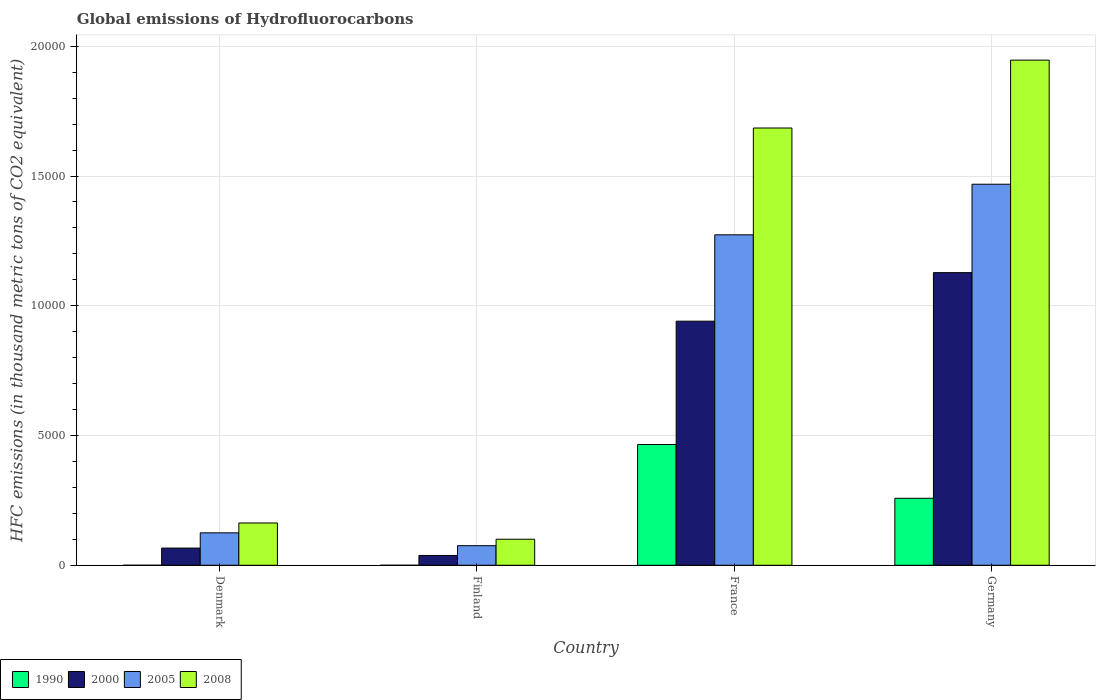Are the number of bars per tick equal to the number of legend labels?
Keep it short and to the point. Yes. What is the label of the 3rd group of bars from the left?
Offer a terse response. France. What is the global emissions of Hydrofluorocarbons in 2008 in France?
Make the answer very short. 1.69e+04. Across all countries, what is the maximum global emissions of Hydrofluorocarbons in 2005?
Give a very brief answer. 1.47e+04. Across all countries, what is the minimum global emissions of Hydrofluorocarbons in 2008?
Offer a very short reply. 1003.2. In which country was the global emissions of Hydrofluorocarbons in 2005 minimum?
Your answer should be compact. Finland. What is the total global emissions of Hydrofluorocarbons in 2000 in the graph?
Keep it short and to the point. 2.17e+04. What is the difference between the global emissions of Hydrofluorocarbons in 1990 in Finland and that in France?
Keep it short and to the point. -4654.2. What is the difference between the global emissions of Hydrofluorocarbons in 2008 in France and the global emissions of Hydrofluorocarbons in 2005 in Finland?
Your answer should be compact. 1.61e+04. What is the average global emissions of Hydrofluorocarbons in 2000 per country?
Keep it short and to the point. 5431.1. What is the difference between the global emissions of Hydrofluorocarbons of/in 2005 and global emissions of Hydrofluorocarbons of/in 1990 in Finland?
Your answer should be compact. 754.8. What is the ratio of the global emissions of Hydrofluorocarbons in 2008 in Denmark to that in France?
Offer a very short reply. 0.1. Is the global emissions of Hydrofluorocarbons in 2005 in Denmark less than that in France?
Offer a terse response. Yes. Is the difference between the global emissions of Hydrofluorocarbons in 2005 in Denmark and Finland greater than the difference between the global emissions of Hydrofluorocarbons in 1990 in Denmark and Finland?
Offer a terse response. Yes. What is the difference between the highest and the second highest global emissions of Hydrofluorocarbons in 2005?
Keep it short and to the point. -1.34e+04. What is the difference between the highest and the lowest global emissions of Hydrofluorocarbons in 2005?
Your response must be concise. 1.39e+04. Is the sum of the global emissions of Hydrofluorocarbons in 2000 in Finland and Germany greater than the maximum global emissions of Hydrofluorocarbons in 1990 across all countries?
Keep it short and to the point. Yes. Is it the case that in every country, the sum of the global emissions of Hydrofluorocarbons in 2008 and global emissions of Hydrofluorocarbons in 2005 is greater than the sum of global emissions of Hydrofluorocarbons in 2000 and global emissions of Hydrofluorocarbons in 1990?
Your response must be concise. Yes. How many bars are there?
Keep it short and to the point. 16. What is the difference between two consecutive major ticks on the Y-axis?
Your response must be concise. 5000. Are the values on the major ticks of Y-axis written in scientific E-notation?
Keep it short and to the point. No. Does the graph contain grids?
Offer a very short reply. Yes. Where does the legend appear in the graph?
Your answer should be very brief. Bottom left. How many legend labels are there?
Give a very brief answer. 4. How are the legend labels stacked?
Offer a terse response. Horizontal. What is the title of the graph?
Give a very brief answer. Global emissions of Hydrofluorocarbons. What is the label or title of the Y-axis?
Offer a very short reply. HFC emissions (in thousand metric tons of CO2 equivalent). What is the HFC emissions (in thousand metric tons of CO2 equivalent) of 2000 in Denmark?
Give a very brief answer. 662.2. What is the HFC emissions (in thousand metric tons of CO2 equivalent) in 2005 in Denmark?
Provide a short and direct response. 1249.5. What is the HFC emissions (in thousand metric tons of CO2 equivalent) in 2008 in Denmark?
Provide a succinct answer. 1629.6. What is the HFC emissions (in thousand metric tons of CO2 equivalent) in 1990 in Finland?
Provide a short and direct response. 0.1. What is the HFC emissions (in thousand metric tons of CO2 equivalent) in 2000 in Finland?
Keep it short and to the point. 378.2. What is the HFC emissions (in thousand metric tons of CO2 equivalent) of 2005 in Finland?
Your response must be concise. 754.9. What is the HFC emissions (in thousand metric tons of CO2 equivalent) in 2008 in Finland?
Your response must be concise. 1003.2. What is the HFC emissions (in thousand metric tons of CO2 equivalent) of 1990 in France?
Provide a succinct answer. 4654.3. What is the HFC emissions (in thousand metric tons of CO2 equivalent) of 2000 in France?
Offer a very short reply. 9406.4. What is the HFC emissions (in thousand metric tons of CO2 equivalent) in 2005 in France?
Offer a very short reply. 1.27e+04. What is the HFC emissions (in thousand metric tons of CO2 equivalent) in 2008 in France?
Offer a very short reply. 1.69e+04. What is the HFC emissions (in thousand metric tons of CO2 equivalent) of 1990 in Germany?
Offer a terse response. 2581.5. What is the HFC emissions (in thousand metric tons of CO2 equivalent) in 2000 in Germany?
Make the answer very short. 1.13e+04. What is the HFC emissions (in thousand metric tons of CO2 equivalent) in 2005 in Germany?
Make the answer very short. 1.47e+04. What is the HFC emissions (in thousand metric tons of CO2 equivalent) in 2008 in Germany?
Offer a very short reply. 1.95e+04. Across all countries, what is the maximum HFC emissions (in thousand metric tons of CO2 equivalent) of 1990?
Make the answer very short. 4654.3. Across all countries, what is the maximum HFC emissions (in thousand metric tons of CO2 equivalent) in 2000?
Your response must be concise. 1.13e+04. Across all countries, what is the maximum HFC emissions (in thousand metric tons of CO2 equivalent) in 2005?
Your response must be concise. 1.47e+04. Across all countries, what is the maximum HFC emissions (in thousand metric tons of CO2 equivalent) in 2008?
Give a very brief answer. 1.95e+04. Across all countries, what is the minimum HFC emissions (in thousand metric tons of CO2 equivalent) of 1990?
Provide a short and direct response. 0.1. Across all countries, what is the minimum HFC emissions (in thousand metric tons of CO2 equivalent) of 2000?
Ensure brevity in your answer.  378.2. Across all countries, what is the minimum HFC emissions (in thousand metric tons of CO2 equivalent) in 2005?
Keep it short and to the point. 754.9. Across all countries, what is the minimum HFC emissions (in thousand metric tons of CO2 equivalent) in 2008?
Ensure brevity in your answer.  1003.2. What is the total HFC emissions (in thousand metric tons of CO2 equivalent) of 1990 in the graph?
Offer a terse response. 7236.2. What is the total HFC emissions (in thousand metric tons of CO2 equivalent) in 2000 in the graph?
Give a very brief answer. 2.17e+04. What is the total HFC emissions (in thousand metric tons of CO2 equivalent) in 2005 in the graph?
Offer a very short reply. 2.94e+04. What is the total HFC emissions (in thousand metric tons of CO2 equivalent) in 2008 in the graph?
Your response must be concise. 3.90e+04. What is the difference between the HFC emissions (in thousand metric tons of CO2 equivalent) of 2000 in Denmark and that in Finland?
Your answer should be very brief. 284. What is the difference between the HFC emissions (in thousand metric tons of CO2 equivalent) of 2005 in Denmark and that in Finland?
Offer a terse response. 494.6. What is the difference between the HFC emissions (in thousand metric tons of CO2 equivalent) in 2008 in Denmark and that in Finland?
Ensure brevity in your answer.  626.4. What is the difference between the HFC emissions (in thousand metric tons of CO2 equivalent) in 1990 in Denmark and that in France?
Your answer should be very brief. -4654. What is the difference between the HFC emissions (in thousand metric tons of CO2 equivalent) in 2000 in Denmark and that in France?
Offer a very short reply. -8744.2. What is the difference between the HFC emissions (in thousand metric tons of CO2 equivalent) of 2005 in Denmark and that in France?
Your answer should be compact. -1.15e+04. What is the difference between the HFC emissions (in thousand metric tons of CO2 equivalent) in 2008 in Denmark and that in France?
Offer a very short reply. -1.52e+04. What is the difference between the HFC emissions (in thousand metric tons of CO2 equivalent) of 1990 in Denmark and that in Germany?
Offer a terse response. -2581.2. What is the difference between the HFC emissions (in thousand metric tons of CO2 equivalent) in 2000 in Denmark and that in Germany?
Give a very brief answer. -1.06e+04. What is the difference between the HFC emissions (in thousand metric tons of CO2 equivalent) of 2005 in Denmark and that in Germany?
Make the answer very short. -1.34e+04. What is the difference between the HFC emissions (in thousand metric tons of CO2 equivalent) of 2008 in Denmark and that in Germany?
Make the answer very short. -1.78e+04. What is the difference between the HFC emissions (in thousand metric tons of CO2 equivalent) in 1990 in Finland and that in France?
Make the answer very short. -4654.2. What is the difference between the HFC emissions (in thousand metric tons of CO2 equivalent) of 2000 in Finland and that in France?
Provide a succinct answer. -9028.2. What is the difference between the HFC emissions (in thousand metric tons of CO2 equivalent) of 2005 in Finland and that in France?
Ensure brevity in your answer.  -1.20e+04. What is the difference between the HFC emissions (in thousand metric tons of CO2 equivalent) in 2008 in Finland and that in France?
Offer a very short reply. -1.58e+04. What is the difference between the HFC emissions (in thousand metric tons of CO2 equivalent) of 1990 in Finland and that in Germany?
Provide a short and direct response. -2581.4. What is the difference between the HFC emissions (in thousand metric tons of CO2 equivalent) of 2000 in Finland and that in Germany?
Ensure brevity in your answer.  -1.09e+04. What is the difference between the HFC emissions (in thousand metric tons of CO2 equivalent) of 2005 in Finland and that in Germany?
Offer a terse response. -1.39e+04. What is the difference between the HFC emissions (in thousand metric tons of CO2 equivalent) in 2008 in Finland and that in Germany?
Keep it short and to the point. -1.85e+04. What is the difference between the HFC emissions (in thousand metric tons of CO2 equivalent) in 1990 in France and that in Germany?
Keep it short and to the point. 2072.8. What is the difference between the HFC emissions (in thousand metric tons of CO2 equivalent) in 2000 in France and that in Germany?
Provide a succinct answer. -1871.2. What is the difference between the HFC emissions (in thousand metric tons of CO2 equivalent) in 2005 in France and that in Germany?
Make the answer very short. -1949.9. What is the difference between the HFC emissions (in thousand metric tons of CO2 equivalent) in 2008 in France and that in Germany?
Offer a very short reply. -2615.7. What is the difference between the HFC emissions (in thousand metric tons of CO2 equivalent) in 1990 in Denmark and the HFC emissions (in thousand metric tons of CO2 equivalent) in 2000 in Finland?
Keep it short and to the point. -377.9. What is the difference between the HFC emissions (in thousand metric tons of CO2 equivalent) in 1990 in Denmark and the HFC emissions (in thousand metric tons of CO2 equivalent) in 2005 in Finland?
Keep it short and to the point. -754.6. What is the difference between the HFC emissions (in thousand metric tons of CO2 equivalent) in 1990 in Denmark and the HFC emissions (in thousand metric tons of CO2 equivalent) in 2008 in Finland?
Provide a short and direct response. -1002.9. What is the difference between the HFC emissions (in thousand metric tons of CO2 equivalent) in 2000 in Denmark and the HFC emissions (in thousand metric tons of CO2 equivalent) in 2005 in Finland?
Offer a very short reply. -92.7. What is the difference between the HFC emissions (in thousand metric tons of CO2 equivalent) of 2000 in Denmark and the HFC emissions (in thousand metric tons of CO2 equivalent) of 2008 in Finland?
Your answer should be very brief. -341. What is the difference between the HFC emissions (in thousand metric tons of CO2 equivalent) of 2005 in Denmark and the HFC emissions (in thousand metric tons of CO2 equivalent) of 2008 in Finland?
Give a very brief answer. 246.3. What is the difference between the HFC emissions (in thousand metric tons of CO2 equivalent) of 1990 in Denmark and the HFC emissions (in thousand metric tons of CO2 equivalent) of 2000 in France?
Offer a very short reply. -9406.1. What is the difference between the HFC emissions (in thousand metric tons of CO2 equivalent) in 1990 in Denmark and the HFC emissions (in thousand metric tons of CO2 equivalent) in 2005 in France?
Keep it short and to the point. -1.27e+04. What is the difference between the HFC emissions (in thousand metric tons of CO2 equivalent) in 1990 in Denmark and the HFC emissions (in thousand metric tons of CO2 equivalent) in 2008 in France?
Provide a short and direct response. -1.69e+04. What is the difference between the HFC emissions (in thousand metric tons of CO2 equivalent) of 2000 in Denmark and the HFC emissions (in thousand metric tons of CO2 equivalent) of 2005 in France?
Your answer should be very brief. -1.21e+04. What is the difference between the HFC emissions (in thousand metric tons of CO2 equivalent) in 2000 in Denmark and the HFC emissions (in thousand metric tons of CO2 equivalent) in 2008 in France?
Provide a short and direct response. -1.62e+04. What is the difference between the HFC emissions (in thousand metric tons of CO2 equivalent) of 2005 in Denmark and the HFC emissions (in thousand metric tons of CO2 equivalent) of 2008 in France?
Give a very brief answer. -1.56e+04. What is the difference between the HFC emissions (in thousand metric tons of CO2 equivalent) in 1990 in Denmark and the HFC emissions (in thousand metric tons of CO2 equivalent) in 2000 in Germany?
Offer a very short reply. -1.13e+04. What is the difference between the HFC emissions (in thousand metric tons of CO2 equivalent) in 1990 in Denmark and the HFC emissions (in thousand metric tons of CO2 equivalent) in 2005 in Germany?
Ensure brevity in your answer.  -1.47e+04. What is the difference between the HFC emissions (in thousand metric tons of CO2 equivalent) of 1990 in Denmark and the HFC emissions (in thousand metric tons of CO2 equivalent) of 2008 in Germany?
Your answer should be very brief. -1.95e+04. What is the difference between the HFC emissions (in thousand metric tons of CO2 equivalent) of 2000 in Denmark and the HFC emissions (in thousand metric tons of CO2 equivalent) of 2005 in Germany?
Give a very brief answer. -1.40e+04. What is the difference between the HFC emissions (in thousand metric tons of CO2 equivalent) of 2000 in Denmark and the HFC emissions (in thousand metric tons of CO2 equivalent) of 2008 in Germany?
Your answer should be compact. -1.88e+04. What is the difference between the HFC emissions (in thousand metric tons of CO2 equivalent) in 2005 in Denmark and the HFC emissions (in thousand metric tons of CO2 equivalent) in 2008 in Germany?
Keep it short and to the point. -1.82e+04. What is the difference between the HFC emissions (in thousand metric tons of CO2 equivalent) in 1990 in Finland and the HFC emissions (in thousand metric tons of CO2 equivalent) in 2000 in France?
Your response must be concise. -9406.3. What is the difference between the HFC emissions (in thousand metric tons of CO2 equivalent) in 1990 in Finland and the HFC emissions (in thousand metric tons of CO2 equivalent) in 2005 in France?
Keep it short and to the point. -1.27e+04. What is the difference between the HFC emissions (in thousand metric tons of CO2 equivalent) of 1990 in Finland and the HFC emissions (in thousand metric tons of CO2 equivalent) of 2008 in France?
Offer a very short reply. -1.69e+04. What is the difference between the HFC emissions (in thousand metric tons of CO2 equivalent) of 2000 in Finland and the HFC emissions (in thousand metric tons of CO2 equivalent) of 2005 in France?
Offer a very short reply. -1.24e+04. What is the difference between the HFC emissions (in thousand metric tons of CO2 equivalent) in 2000 in Finland and the HFC emissions (in thousand metric tons of CO2 equivalent) in 2008 in France?
Make the answer very short. -1.65e+04. What is the difference between the HFC emissions (in thousand metric tons of CO2 equivalent) in 2005 in Finland and the HFC emissions (in thousand metric tons of CO2 equivalent) in 2008 in France?
Make the answer very short. -1.61e+04. What is the difference between the HFC emissions (in thousand metric tons of CO2 equivalent) of 1990 in Finland and the HFC emissions (in thousand metric tons of CO2 equivalent) of 2000 in Germany?
Provide a succinct answer. -1.13e+04. What is the difference between the HFC emissions (in thousand metric tons of CO2 equivalent) in 1990 in Finland and the HFC emissions (in thousand metric tons of CO2 equivalent) in 2005 in Germany?
Your response must be concise. -1.47e+04. What is the difference between the HFC emissions (in thousand metric tons of CO2 equivalent) of 1990 in Finland and the HFC emissions (in thousand metric tons of CO2 equivalent) of 2008 in Germany?
Offer a very short reply. -1.95e+04. What is the difference between the HFC emissions (in thousand metric tons of CO2 equivalent) of 2000 in Finland and the HFC emissions (in thousand metric tons of CO2 equivalent) of 2005 in Germany?
Your answer should be compact. -1.43e+04. What is the difference between the HFC emissions (in thousand metric tons of CO2 equivalent) in 2000 in Finland and the HFC emissions (in thousand metric tons of CO2 equivalent) in 2008 in Germany?
Keep it short and to the point. -1.91e+04. What is the difference between the HFC emissions (in thousand metric tons of CO2 equivalent) in 2005 in Finland and the HFC emissions (in thousand metric tons of CO2 equivalent) in 2008 in Germany?
Give a very brief answer. -1.87e+04. What is the difference between the HFC emissions (in thousand metric tons of CO2 equivalent) of 1990 in France and the HFC emissions (in thousand metric tons of CO2 equivalent) of 2000 in Germany?
Your answer should be very brief. -6623.3. What is the difference between the HFC emissions (in thousand metric tons of CO2 equivalent) of 1990 in France and the HFC emissions (in thousand metric tons of CO2 equivalent) of 2005 in Germany?
Make the answer very short. -1.00e+04. What is the difference between the HFC emissions (in thousand metric tons of CO2 equivalent) in 1990 in France and the HFC emissions (in thousand metric tons of CO2 equivalent) in 2008 in Germany?
Give a very brief answer. -1.48e+04. What is the difference between the HFC emissions (in thousand metric tons of CO2 equivalent) of 2000 in France and the HFC emissions (in thousand metric tons of CO2 equivalent) of 2005 in Germany?
Your response must be concise. -5278.2. What is the difference between the HFC emissions (in thousand metric tons of CO2 equivalent) of 2000 in France and the HFC emissions (in thousand metric tons of CO2 equivalent) of 2008 in Germany?
Make the answer very short. -1.01e+04. What is the difference between the HFC emissions (in thousand metric tons of CO2 equivalent) in 2005 in France and the HFC emissions (in thousand metric tons of CO2 equivalent) in 2008 in Germany?
Your answer should be very brief. -6732.1. What is the average HFC emissions (in thousand metric tons of CO2 equivalent) of 1990 per country?
Offer a terse response. 1809.05. What is the average HFC emissions (in thousand metric tons of CO2 equivalent) in 2000 per country?
Provide a succinct answer. 5431.1. What is the average HFC emissions (in thousand metric tons of CO2 equivalent) of 2005 per country?
Ensure brevity in your answer.  7355.93. What is the average HFC emissions (in thousand metric tons of CO2 equivalent) of 2008 per country?
Your answer should be very brief. 9737.67. What is the difference between the HFC emissions (in thousand metric tons of CO2 equivalent) of 1990 and HFC emissions (in thousand metric tons of CO2 equivalent) of 2000 in Denmark?
Ensure brevity in your answer.  -661.9. What is the difference between the HFC emissions (in thousand metric tons of CO2 equivalent) of 1990 and HFC emissions (in thousand metric tons of CO2 equivalent) of 2005 in Denmark?
Offer a very short reply. -1249.2. What is the difference between the HFC emissions (in thousand metric tons of CO2 equivalent) in 1990 and HFC emissions (in thousand metric tons of CO2 equivalent) in 2008 in Denmark?
Your answer should be compact. -1629.3. What is the difference between the HFC emissions (in thousand metric tons of CO2 equivalent) in 2000 and HFC emissions (in thousand metric tons of CO2 equivalent) in 2005 in Denmark?
Your answer should be very brief. -587.3. What is the difference between the HFC emissions (in thousand metric tons of CO2 equivalent) in 2000 and HFC emissions (in thousand metric tons of CO2 equivalent) in 2008 in Denmark?
Make the answer very short. -967.4. What is the difference between the HFC emissions (in thousand metric tons of CO2 equivalent) in 2005 and HFC emissions (in thousand metric tons of CO2 equivalent) in 2008 in Denmark?
Provide a short and direct response. -380.1. What is the difference between the HFC emissions (in thousand metric tons of CO2 equivalent) in 1990 and HFC emissions (in thousand metric tons of CO2 equivalent) in 2000 in Finland?
Ensure brevity in your answer.  -378.1. What is the difference between the HFC emissions (in thousand metric tons of CO2 equivalent) in 1990 and HFC emissions (in thousand metric tons of CO2 equivalent) in 2005 in Finland?
Give a very brief answer. -754.8. What is the difference between the HFC emissions (in thousand metric tons of CO2 equivalent) in 1990 and HFC emissions (in thousand metric tons of CO2 equivalent) in 2008 in Finland?
Your answer should be compact. -1003.1. What is the difference between the HFC emissions (in thousand metric tons of CO2 equivalent) of 2000 and HFC emissions (in thousand metric tons of CO2 equivalent) of 2005 in Finland?
Your response must be concise. -376.7. What is the difference between the HFC emissions (in thousand metric tons of CO2 equivalent) of 2000 and HFC emissions (in thousand metric tons of CO2 equivalent) of 2008 in Finland?
Provide a short and direct response. -625. What is the difference between the HFC emissions (in thousand metric tons of CO2 equivalent) in 2005 and HFC emissions (in thousand metric tons of CO2 equivalent) in 2008 in Finland?
Offer a terse response. -248.3. What is the difference between the HFC emissions (in thousand metric tons of CO2 equivalent) of 1990 and HFC emissions (in thousand metric tons of CO2 equivalent) of 2000 in France?
Give a very brief answer. -4752.1. What is the difference between the HFC emissions (in thousand metric tons of CO2 equivalent) of 1990 and HFC emissions (in thousand metric tons of CO2 equivalent) of 2005 in France?
Ensure brevity in your answer.  -8080.4. What is the difference between the HFC emissions (in thousand metric tons of CO2 equivalent) of 1990 and HFC emissions (in thousand metric tons of CO2 equivalent) of 2008 in France?
Make the answer very short. -1.22e+04. What is the difference between the HFC emissions (in thousand metric tons of CO2 equivalent) of 2000 and HFC emissions (in thousand metric tons of CO2 equivalent) of 2005 in France?
Provide a succinct answer. -3328.3. What is the difference between the HFC emissions (in thousand metric tons of CO2 equivalent) in 2000 and HFC emissions (in thousand metric tons of CO2 equivalent) in 2008 in France?
Offer a very short reply. -7444.7. What is the difference between the HFC emissions (in thousand metric tons of CO2 equivalent) of 2005 and HFC emissions (in thousand metric tons of CO2 equivalent) of 2008 in France?
Keep it short and to the point. -4116.4. What is the difference between the HFC emissions (in thousand metric tons of CO2 equivalent) in 1990 and HFC emissions (in thousand metric tons of CO2 equivalent) in 2000 in Germany?
Provide a short and direct response. -8696.1. What is the difference between the HFC emissions (in thousand metric tons of CO2 equivalent) of 1990 and HFC emissions (in thousand metric tons of CO2 equivalent) of 2005 in Germany?
Ensure brevity in your answer.  -1.21e+04. What is the difference between the HFC emissions (in thousand metric tons of CO2 equivalent) in 1990 and HFC emissions (in thousand metric tons of CO2 equivalent) in 2008 in Germany?
Your response must be concise. -1.69e+04. What is the difference between the HFC emissions (in thousand metric tons of CO2 equivalent) in 2000 and HFC emissions (in thousand metric tons of CO2 equivalent) in 2005 in Germany?
Offer a very short reply. -3407. What is the difference between the HFC emissions (in thousand metric tons of CO2 equivalent) in 2000 and HFC emissions (in thousand metric tons of CO2 equivalent) in 2008 in Germany?
Your response must be concise. -8189.2. What is the difference between the HFC emissions (in thousand metric tons of CO2 equivalent) in 2005 and HFC emissions (in thousand metric tons of CO2 equivalent) in 2008 in Germany?
Offer a very short reply. -4782.2. What is the ratio of the HFC emissions (in thousand metric tons of CO2 equivalent) in 1990 in Denmark to that in Finland?
Give a very brief answer. 3. What is the ratio of the HFC emissions (in thousand metric tons of CO2 equivalent) of 2000 in Denmark to that in Finland?
Offer a terse response. 1.75. What is the ratio of the HFC emissions (in thousand metric tons of CO2 equivalent) of 2005 in Denmark to that in Finland?
Your answer should be compact. 1.66. What is the ratio of the HFC emissions (in thousand metric tons of CO2 equivalent) of 2008 in Denmark to that in Finland?
Make the answer very short. 1.62. What is the ratio of the HFC emissions (in thousand metric tons of CO2 equivalent) of 2000 in Denmark to that in France?
Your answer should be very brief. 0.07. What is the ratio of the HFC emissions (in thousand metric tons of CO2 equivalent) of 2005 in Denmark to that in France?
Offer a very short reply. 0.1. What is the ratio of the HFC emissions (in thousand metric tons of CO2 equivalent) in 2008 in Denmark to that in France?
Give a very brief answer. 0.1. What is the ratio of the HFC emissions (in thousand metric tons of CO2 equivalent) in 1990 in Denmark to that in Germany?
Provide a succinct answer. 0. What is the ratio of the HFC emissions (in thousand metric tons of CO2 equivalent) in 2000 in Denmark to that in Germany?
Your answer should be compact. 0.06. What is the ratio of the HFC emissions (in thousand metric tons of CO2 equivalent) in 2005 in Denmark to that in Germany?
Your answer should be very brief. 0.09. What is the ratio of the HFC emissions (in thousand metric tons of CO2 equivalent) in 2008 in Denmark to that in Germany?
Make the answer very short. 0.08. What is the ratio of the HFC emissions (in thousand metric tons of CO2 equivalent) of 1990 in Finland to that in France?
Keep it short and to the point. 0. What is the ratio of the HFC emissions (in thousand metric tons of CO2 equivalent) of 2000 in Finland to that in France?
Ensure brevity in your answer.  0.04. What is the ratio of the HFC emissions (in thousand metric tons of CO2 equivalent) of 2005 in Finland to that in France?
Provide a short and direct response. 0.06. What is the ratio of the HFC emissions (in thousand metric tons of CO2 equivalent) in 2008 in Finland to that in France?
Your answer should be compact. 0.06. What is the ratio of the HFC emissions (in thousand metric tons of CO2 equivalent) of 1990 in Finland to that in Germany?
Offer a terse response. 0. What is the ratio of the HFC emissions (in thousand metric tons of CO2 equivalent) of 2000 in Finland to that in Germany?
Offer a very short reply. 0.03. What is the ratio of the HFC emissions (in thousand metric tons of CO2 equivalent) of 2005 in Finland to that in Germany?
Ensure brevity in your answer.  0.05. What is the ratio of the HFC emissions (in thousand metric tons of CO2 equivalent) of 2008 in Finland to that in Germany?
Provide a succinct answer. 0.05. What is the ratio of the HFC emissions (in thousand metric tons of CO2 equivalent) in 1990 in France to that in Germany?
Your answer should be very brief. 1.8. What is the ratio of the HFC emissions (in thousand metric tons of CO2 equivalent) of 2000 in France to that in Germany?
Your answer should be compact. 0.83. What is the ratio of the HFC emissions (in thousand metric tons of CO2 equivalent) of 2005 in France to that in Germany?
Your response must be concise. 0.87. What is the ratio of the HFC emissions (in thousand metric tons of CO2 equivalent) of 2008 in France to that in Germany?
Provide a succinct answer. 0.87. What is the difference between the highest and the second highest HFC emissions (in thousand metric tons of CO2 equivalent) in 1990?
Offer a terse response. 2072.8. What is the difference between the highest and the second highest HFC emissions (in thousand metric tons of CO2 equivalent) in 2000?
Make the answer very short. 1871.2. What is the difference between the highest and the second highest HFC emissions (in thousand metric tons of CO2 equivalent) in 2005?
Keep it short and to the point. 1949.9. What is the difference between the highest and the second highest HFC emissions (in thousand metric tons of CO2 equivalent) of 2008?
Offer a terse response. 2615.7. What is the difference between the highest and the lowest HFC emissions (in thousand metric tons of CO2 equivalent) in 1990?
Keep it short and to the point. 4654.2. What is the difference between the highest and the lowest HFC emissions (in thousand metric tons of CO2 equivalent) in 2000?
Keep it short and to the point. 1.09e+04. What is the difference between the highest and the lowest HFC emissions (in thousand metric tons of CO2 equivalent) in 2005?
Give a very brief answer. 1.39e+04. What is the difference between the highest and the lowest HFC emissions (in thousand metric tons of CO2 equivalent) in 2008?
Give a very brief answer. 1.85e+04. 